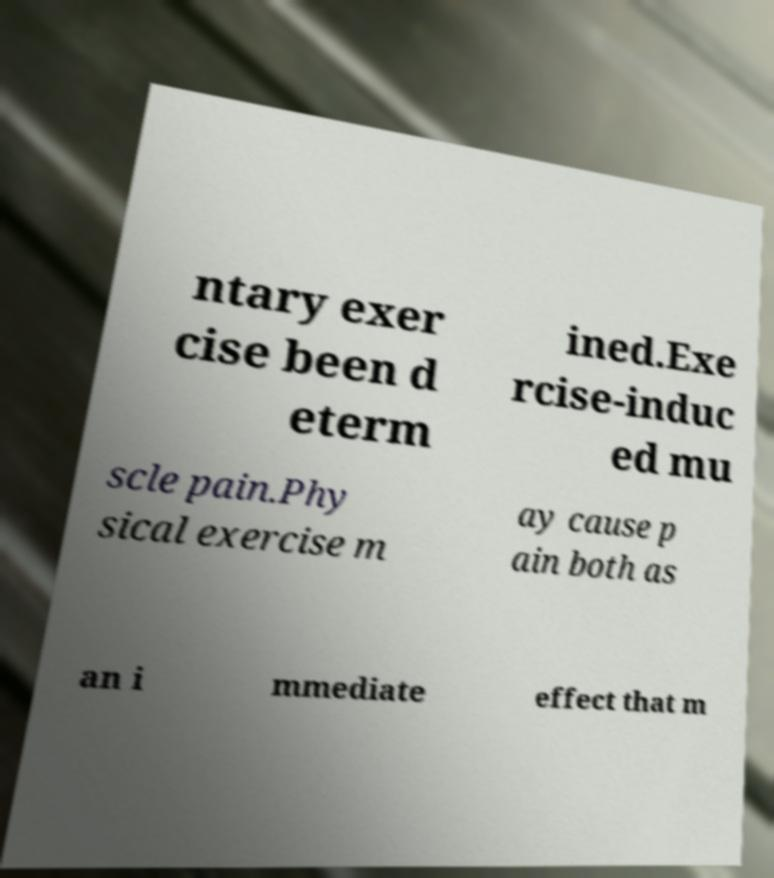Could you assist in decoding the text presented in this image and type it out clearly? ntary exer cise been d eterm ined.Exe rcise-induc ed mu scle pain.Phy sical exercise m ay cause p ain both as an i mmediate effect that m 